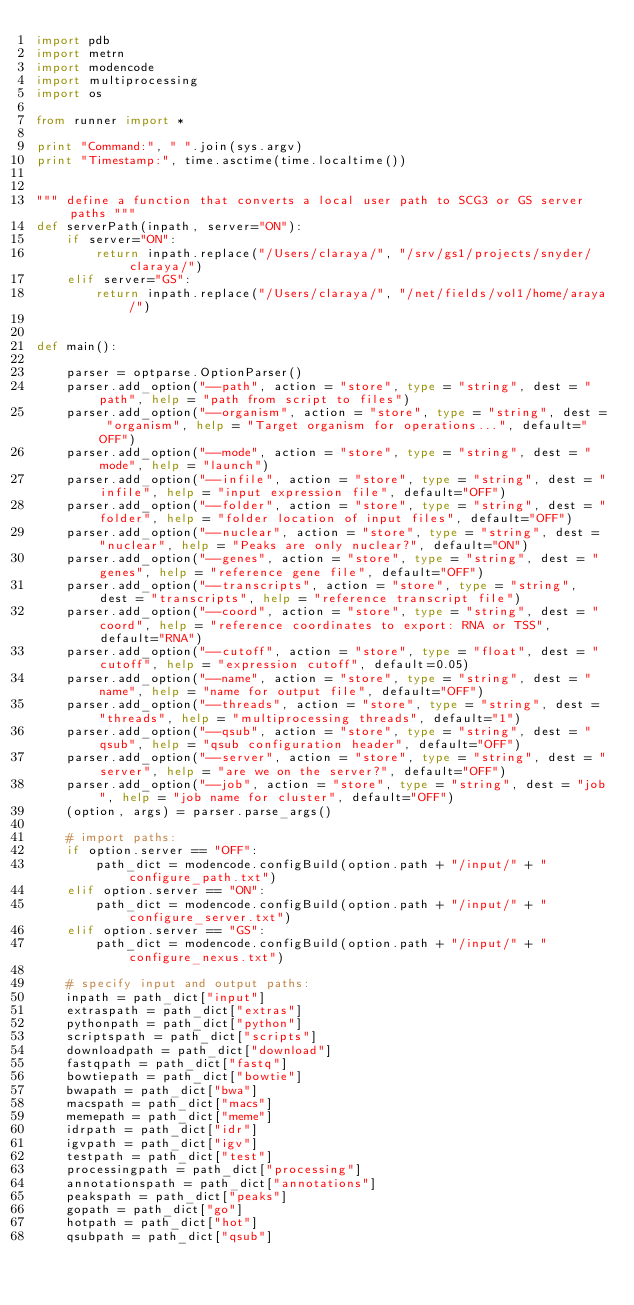<code> <loc_0><loc_0><loc_500><loc_500><_Python_>import pdb
import metrn
import modencode
import multiprocessing
import os

from runner import *

print "Command:", " ".join(sys.argv)
print "Timestamp:", time.asctime(time.localtime())


""" define a function that converts a local user path to SCG3 or GS server paths """
def serverPath(inpath, server="ON"):
	if server="ON":
		return inpath.replace("/Users/claraya/", "/srv/gs1/projects/snyder/claraya/")
	elif server="GS":
		return inpath.replace("/Users/claraya/", "/net/fields/vol1/home/araya/")

				
def main():
	
	parser = optparse.OptionParser()
	parser.add_option("--path", action = "store", type = "string", dest = "path", help = "path from script to files")
	parser.add_option("--organism", action = "store", type = "string", dest = "organism", help = "Target organism for operations...", default="OFF")
	parser.add_option("--mode", action = "store", type = "string", dest = "mode", help = "launch")
	parser.add_option("--infile", action = "store", type = "string", dest = "infile", help = "input expression file", default="OFF")
	parser.add_option("--folder", action = "store", type = "string", dest = "folder", help = "folder location of input files", default="OFF")
	parser.add_option("--nuclear", action = "store", type = "string", dest = "nuclear", help = "Peaks are only nuclear?", default="ON")
	parser.add_option("--genes", action = "store", type = "string", dest = "genes", help = "reference gene file", default="OFF")
	parser.add_option("--transcripts", action = "store", type = "string", dest = "transcripts", help = "reference transcript file")
	parser.add_option("--coord", action = "store", type = "string", dest = "coord", help = "reference coordinates to export: RNA or TSS", default="RNA")
	parser.add_option("--cutoff", action = "store", type = "float", dest = "cutoff", help = "expression cutoff", default=0.05)
	parser.add_option("--name", action = "store", type = "string", dest = "name", help = "name for output file", default="OFF")
	parser.add_option("--threads", action = "store", type = "string", dest = "threads", help = "multiprocessing threads", default="1")
	parser.add_option("--qsub", action = "store", type = "string", dest = "qsub", help = "qsub configuration header", default="OFF")
	parser.add_option("--server", action = "store", type = "string", dest = "server", help = "are we on the server?", default="OFF")
	parser.add_option("--job", action = "store", type = "string", dest = "job", help = "job name for cluster", default="OFF")
	(option, args) = parser.parse_args()
	
	# import paths:
	if option.server == "OFF":
		path_dict = modencode.configBuild(option.path + "/input/" + "configure_path.txt")
	elif option.server == "ON":
		path_dict = modencode.configBuild(option.path + "/input/" + "configure_server.txt")
	elif option.server == "GS":
		path_dict = modencode.configBuild(option.path + "/input/" + "configure_nexus.txt")
	
	# specify input and output paths:
	inpath = path_dict["input"]
	extraspath = path_dict["extras"]
	pythonpath = path_dict["python"]
	scriptspath = path_dict["scripts"]
	downloadpath = path_dict["download"]
	fastqpath = path_dict["fastq"]
	bowtiepath = path_dict["bowtie"]
	bwapath = path_dict["bwa"]
	macspath = path_dict["macs"]
	memepath = path_dict["meme"]
	idrpath = path_dict["idr"]
	igvpath = path_dict["igv"]
	testpath = path_dict["test"]
	processingpath = path_dict["processing"]
	annotationspath = path_dict["annotations"]
	peakspath = path_dict["peaks"]
	gopath = path_dict["go"]
	hotpath = path_dict["hot"]
	qsubpath = path_dict["qsub"]
	</code> 